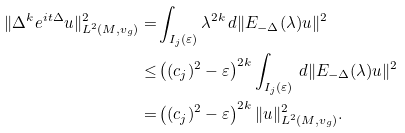<formula> <loc_0><loc_0><loc_500><loc_500>\| \Delta ^ { k } e ^ { i t \Delta } u \| _ { L ^ { 2 } ( M , v _ { g } ) } ^ { 2 } = & \int _ { I _ { j } ( \varepsilon ) } \lambda ^ { 2 k } \, d \| E _ { - \Delta } ( \lambda ) u \| ^ { 2 } \\ \leq & \left ( ( c _ { j } ) ^ { 2 } - \varepsilon \right ) ^ { 2 k } \int _ { I _ { j } ( \varepsilon ) } \, d \| E _ { - \Delta } ( \lambda ) u \| ^ { 2 } \\ = & \left ( ( c _ { j } ) ^ { 2 } - \varepsilon \right ) ^ { 2 k } \| u \| _ { L ^ { 2 } ( M , v _ { g } ) } ^ { 2 } .</formula> 